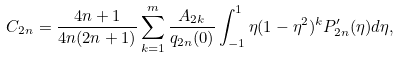Convert formula to latex. <formula><loc_0><loc_0><loc_500><loc_500>C _ { 2 n } = \frac { 4 n + 1 } { 4 n ( 2 n + 1 ) } \sum _ { k = 1 } ^ { m } \frac { A _ { 2 k } } { q _ { 2 n } ( 0 ) } \int _ { - 1 } ^ { 1 } \eta ( 1 - \eta ^ { 2 } ) ^ { k } P ^ { \prime } _ { 2 n } ( \eta ) d \eta ,</formula> 